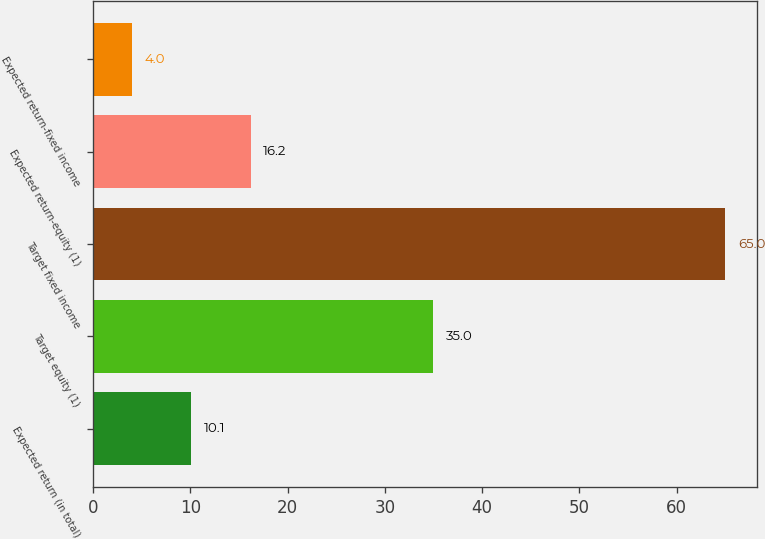Convert chart. <chart><loc_0><loc_0><loc_500><loc_500><bar_chart><fcel>Expected return (in total)<fcel>Target equity (1)<fcel>Target fixed income<fcel>Expected return-equity (1)<fcel>Expected return-fixed income<nl><fcel>10.1<fcel>35<fcel>65<fcel>16.2<fcel>4<nl></chart> 